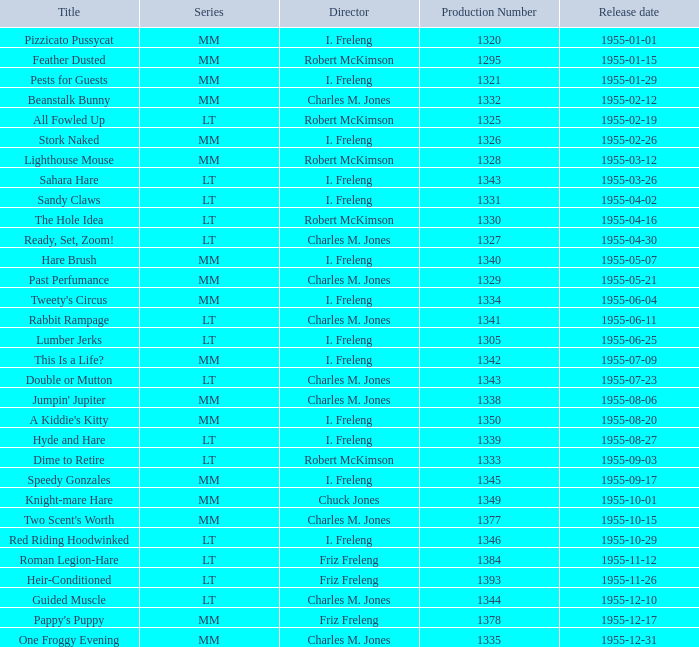What is the designation of the production with a number above 1334, unveiled on 1955-08-27? Hyde and Hare. 